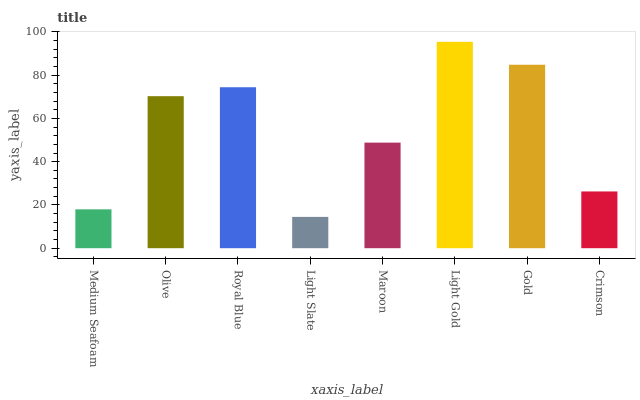Is Olive the minimum?
Answer yes or no. No. Is Olive the maximum?
Answer yes or no. No. Is Olive greater than Medium Seafoam?
Answer yes or no. Yes. Is Medium Seafoam less than Olive?
Answer yes or no. Yes. Is Medium Seafoam greater than Olive?
Answer yes or no. No. Is Olive less than Medium Seafoam?
Answer yes or no. No. Is Olive the high median?
Answer yes or no. Yes. Is Maroon the low median?
Answer yes or no. Yes. Is Light Slate the high median?
Answer yes or no. No. Is Light Slate the low median?
Answer yes or no. No. 